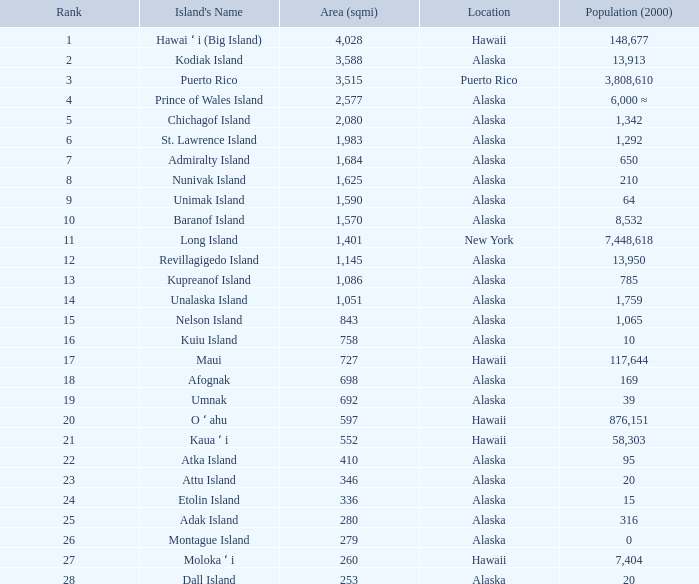What is the largest area in Alaska with a population of 39 and rank over 19? None. 